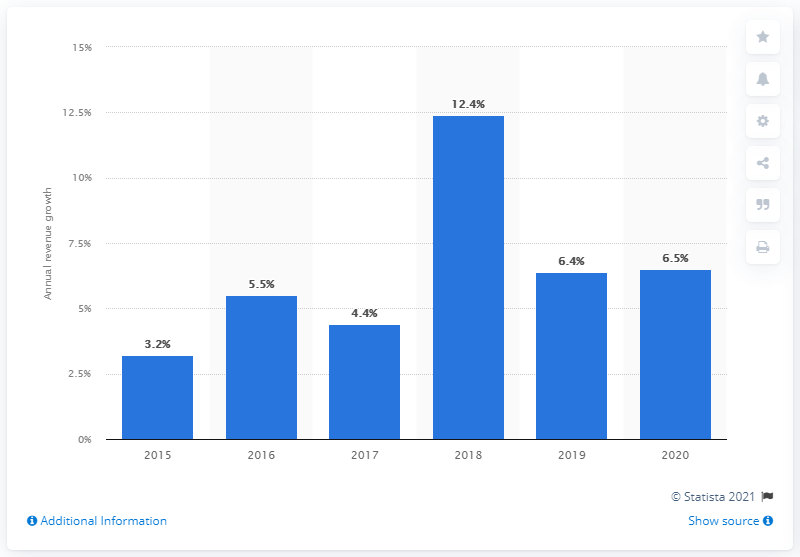Mention a couple of crucial points in this snapshot. The average annual revenue growth of architecture and engineering services between 2015 and 2020 was 6.5%. 